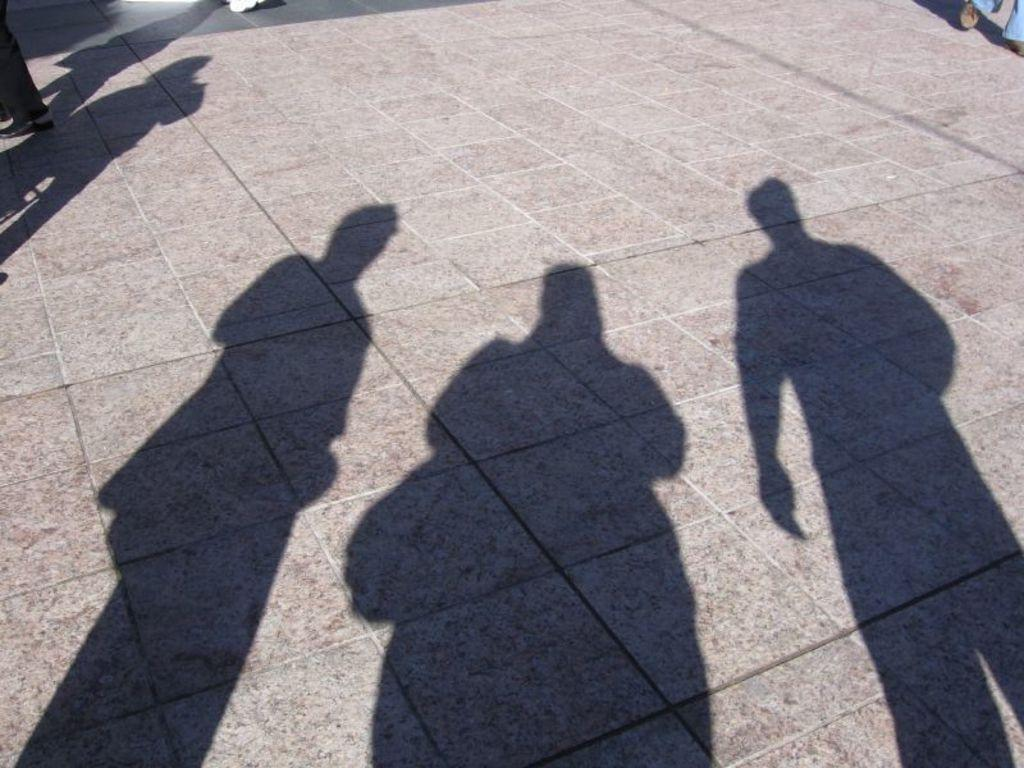How many people's shadows can be seen in the image? There are shadows of three people in the image. Can you describe the position of a person's leg in the image? A person's leg is visible in the top left corner of the image. Where is another person visible in the image? There is a person visible in the top right side of the image. What is the name of the nation that the person in the top right side of the image represents? There is no information about the person's nationality or any nation in the image. 